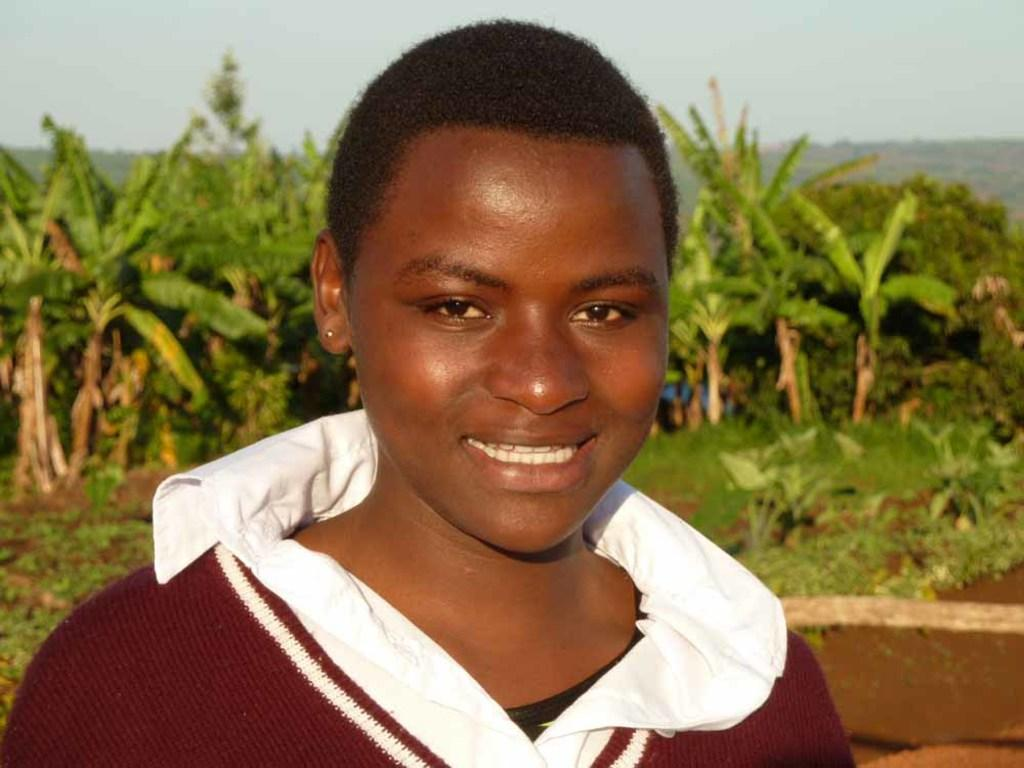Who is the main subject in the foreground of the image? There is a person in the foreground of the image. What is the person doing in the image? The person is smiling. What can be seen in the background of the image? There are many plants visible behind the person. What type of badge is the stranger wearing in the image? There is no stranger present in the image, and therefore no badge can be observed. 